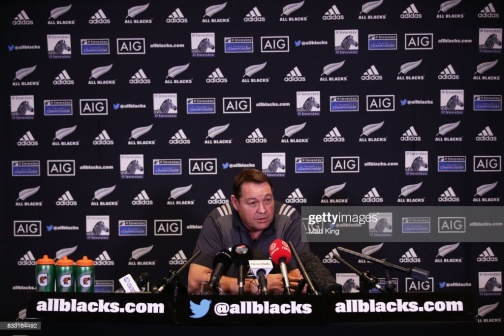What do you think is going on in this snapshot? In the center of the image, a man is seated at a desk, engrossed in a conversation through a microphone. He's dressed in a blue shirt, adding a pop of color to the otherwise monochrome setting. The desk, cluttered with several water bottles, serves as his temporary stage.

Behind him, a wall adorned with logos and text forms a striking backdrop. The logos are predominantly black and white, with occasional blue and orange accents adding a dash of vibrancy. Among the various logos, 'allblacks.com' and 'AIG' are clearly visible, hinting at the possible context of the discussion.

The man's position, slightly to the left of the desk, along with the strategic placement of the logos, creates a balanced composition. Despite the multitude of elements, each object holds its space, contributing to the overall narrative of the image. The image captures a moment, possibly from a live broadcast or a podcast recording, frozen in time. 